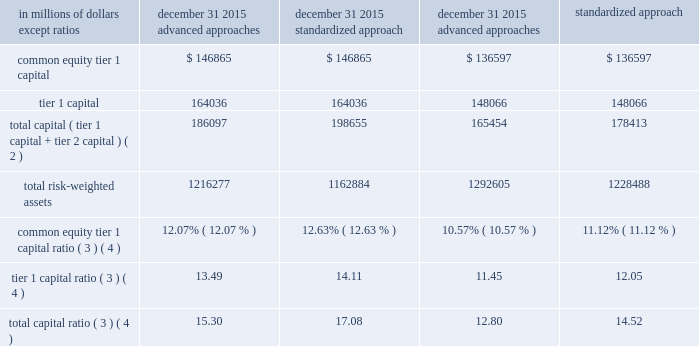Basel iii ( full implementation ) citigroup 2019s capital resources under basel iii ( full implementation ) citi currently estimates that its effective minimum common equity tier 1 capital , tier 1 capital and total capital ratio requirements under the u.s .
Basel iii rules , on a fully implemented basis and assuming a 3% ( 3 % ) gsib surcharge , may be 10% ( 10 % ) , 11.5% ( 11.5 % ) and 13.5% ( 13.5 % ) , respectively .
Further , under the u.s .
Basel iii rules , citi must also comply with a 4% ( 4 % ) minimum tier 1 leverage ratio requirement and an effective 5% ( 5 % ) minimum supplementary leverage ratio requirement .
The tables set forth the capital tiers , total risk-weighted assets , risk-based capital ratios , quarterly adjusted average total assets , total leverage exposure and leverage ratios , assuming full implementation under the u.s .
Basel iii rules , for citi as of december 31 , 2015 and december 31 , 2014 .
Citigroup capital components and ratios under basel iii ( full implementation ) december 31 , 2015 december 31 , 2014 ( 1 ) in millions of dollars , except ratios advanced approaches standardized approach advanced approaches standardized approach .
Common equity tier 1 capital ratio ( 3 ) ( 4 ) 12.07% ( 12.07 % ) 12.63% ( 12.63 % ) 10.57% ( 10.57 % ) 11.12% ( 11.12 % ) tier 1 capital ratio ( 3 ) ( 4 ) 13.49 14.11 11.45 12.05 total capital ratio ( 3 ) ( 4 ) 15.30 17.08 12.80 14.52 in millions of dollars , except ratios december 31 , 2015 december 31 , 2014 ( 1 ) quarterly adjusted average total assets ( 5 ) $ 1724710 $ 1835637 total leverage exposure ( 6 ) 2317849 2492636 tier 1 leverage ratio ( 4 ) 9.51% ( 9.51 % ) 8.07% ( 8.07 % ) supplementary leverage ratio ( 4 ) 7.08 5.94 ( 1 ) restated to reflect the retrospective adoption of asu 2014-01 for lihtc investments , consistent with current period presentation .
( 2 ) under the advanced approaches framework eligible credit reserves that exceed expected credit losses are eligible for inclusion in tier 2 capital to the extent the excess reserves do not exceed 0.6% ( 0.6 % ) of credit risk-weighted assets , which differs from the standardized approach in which the allowance for credit losses is eligible for inclusion in tier 2 capital up to 1.25% ( 1.25 % ) of credit risk-weighted assets , with any excess allowance for credit losses being deducted in arriving at credit risk-weighted assets .
( 3 ) as of december 31 , 2015 and december 31 , 2014 , citi 2019s common equity tier 1 capital , tier 1 capital , and total capital ratios were the lower derived under the basel iii advanced approaches framework .
( 4 ) citi 2019s basel iii capital ratios and related components , on a fully implemented basis , are non-gaap financial measures .
Citi believes these ratios and the related components provide useful information to investors and others by measuring citi 2019s progress against future regulatory capital standards .
( 5 ) tier 1 leverage ratio denominator .
( 6 ) supplementary leverage ratio denominator. .
What is the difference in the tier 1 capital ratio between the advanced approaches and the standardized approach at december 31 , 2015? 
Computations: (13.49 - 14.11)
Answer: -0.62. Basel iii ( full implementation ) citigroup 2019s capital resources under basel iii ( full implementation ) citi currently estimates that its effective minimum common equity tier 1 capital , tier 1 capital and total capital ratio requirements under the u.s .
Basel iii rules , on a fully implemented basis and assuming a 3% ( 3 % ) gsib surcharge , may be 10% ( 10 % ) , 11.5% ( 11.5 % ) and 13.5% ( 13.5 % ) , respectively .
Further , under the u.s .
Basel iii rules , citi must also comply with a 4% ( 4 % ) minimum tier 1 leverage ratio requirement and an effective 5% ( 5 % ) minimum supplementary leverage ratio requirement .
The tables set forth the capital tiers , total risk-weighted assets , risk-based capital ratios , quarterly adjusted average total assets , total leverage exposure and leverage ratios , assuming full implementation under the u.s .
Basel iii rules , for citi as of december 31 , 2015 and december 31 , 2014 .
Citigroup capital components and ratios under basel iii ( full implementation ) december 31 , 2015 december 31 , 2014 ( 1 ) in millions of dollars , except ratios advanced approaches standardized approach advanced approaches standardized approach .
Common equity tier 1 capital ratio ( 3 ) ( 4 ) 12.07% ( 12.07 % ) 12.63% ( 12.63 % ) 10.57% ( 10.57 % ) 11.12% ( 11.12 % ) tier 1 capital ratio ( 3 ) ( 4 ) 13.49 14.11 11.45 12.05 total capital ratio ( 3 ) ( 4 ) 15.30 17.08 12.80 14.52 in millions of dollars , except ratios december 31 , 2015 december 31 , 2014 ( 1 ) quarterly adjusted average total assets ( 5 ) $ 1724710 $ 1835637 total leverage exposure ( 6 ) 2317849 2492636 tier 1 leverage ratio ( 4 ) 9.51% ( 9.51 % ) 8.07% ( 8.07 % ) supplementary leverage ratio ( 4 ) 7.08 5.94 ( 1 ) restated to reflect the retrospective adoption of asu 2014-01 for lihtc investments , consistent with current period presentation .
( 2 ) under the advanced approaches framework eligible credit reserves that exceed expected credit losses are eligible for inclusion in tier 2 capital to the extent the excess reserves do not exceed 0.6% ( 0.6 % ) of credit risk-weighted assets , which differs from the standardized approach in which the allowance for credit losses is eligible for inclusion in tier 2 capital up to 1.25% ( 1.25 % ) of credit risk-weighted assets , with any excess allowance for credit losses being deducted in arriving at credit risk-weighted assets .
( 3 ) as of december 31 , 2015 and december 31 , 2014 , citi 2019s common equity tier 1 capital , tier 1 capital , and total capital ratios were the lower derived under the basel iii advanced approaches framework .
( 4 ) citi 2019s basel iii capital ratios and related components , on a fully implemented basis , are non-gaap financial measures .
Citi believes these ratios and the related components provide useful information to investors and others by measuring citi 2019s progress against future regulatory capital standards .
( 5 ) tier 1 leverage ratio denominator .
( 6 ) supplementary leverage ratio denominator. .
What is the difference in the total capital ratio between the advanced approaches and the standardized approach at december 31 , 2015? 
Computations: (15.30 - 17.08)
Answer: -1.78. 